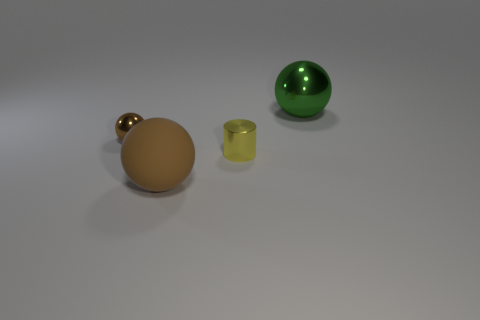Subtract all brown spheres. How many spheres are left? 1 Subtract 1 balls. How many balls are left? 2 Add 1 green cubes. How many objects exist? 5 Subtract all green balls. How many balls are left? 2 Subtract 0 cyan cylinders. How many objects are left? 4 Subtract all spheres. How many objects are left? 1 Subtract all purple spheres. Subtract all gray cubes. How many spheres are left? 3 Subtract all gray cylinders. How many purple balls are left? 0 Subtract all small blue things. Subtract all large green things. How many objects are left? 3 Add 2 matte objects. How many matte objects are left? 3 